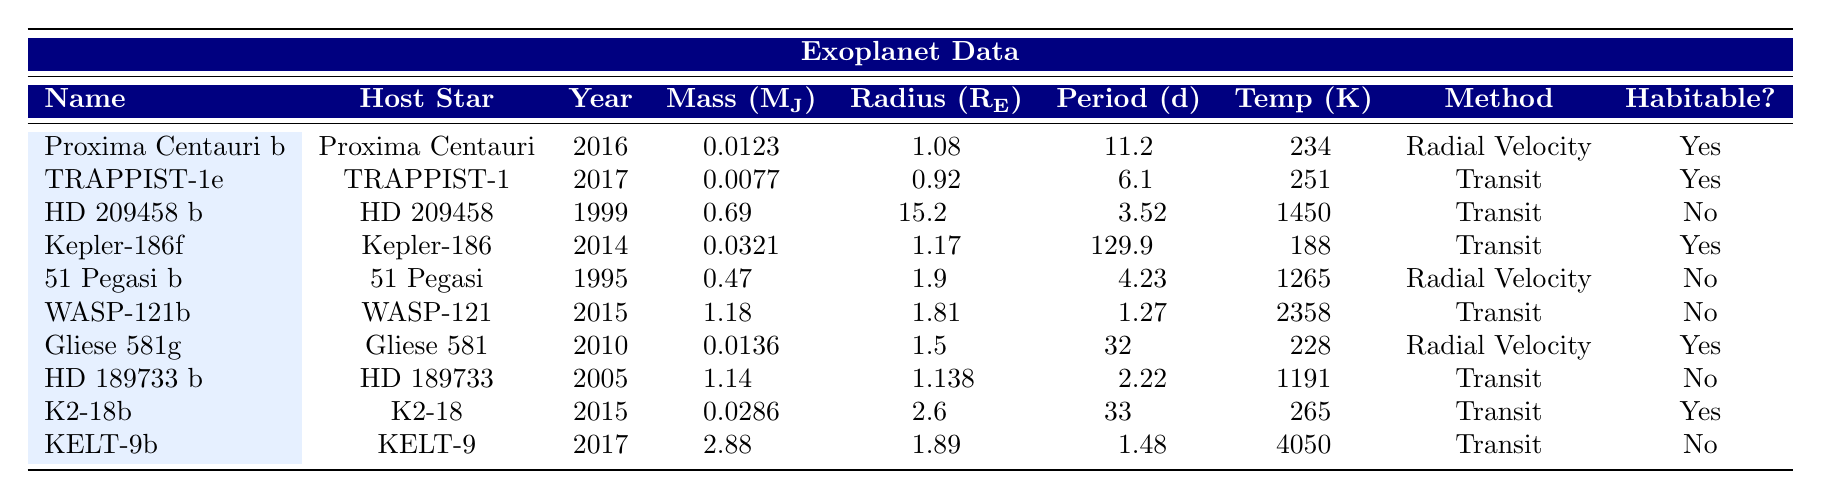What is the host star of Proxima Centauri b? The table lists Proxima Centauri b in the first row, and the associated host star is Proxima Centauri.
Answer: Proxima Centauri What year was K2-18b discovered? The table indicates that K2-18b was discovered in the year listed in its row, which is 2015.
Answer: 2015 Which exoplanet has the highest average temperature? By reviewing the temperature values in the table, KELT-9b has the highest average temperature at 4050 K.
Answer: KELT-9b How many exoplanets in the table are potentially habitable? The table shows three exoplanets with "Yes" in the last column, so there are three potentially habitable exoplanets.
Answer: 3 What is the mass of TRAPPIST-1e in Jupiter masses? The row for TRAPPIST-1e shows a mass of 0.0077 Jupiter masses.
Answer: 0.0077 What is the average mass of the habitable exoplanets listed? The habitable exoplanets and their masses are Proxima Centauri b (0.0123), TRAPPIST-1e (0.0077), Gliese 581g (0.0136), Kepler-186f (0.0321), and K2-18b (0.0286). Adding these gives: 0.0123 + 0.0077 + 0.0136 + 0.0321 + 0.0286 = 0.0943. To find the average, divide by 5 (the number of habitable exoplanets), resulting in an average mass of 0.01886.
Answer: 0.01886 Is there an exoplanet discovered before 2000 that is potentially habitable? According to the table, the only exoplanets discovered before 2000 are 51 Pegasi b and HD 209458 b, both of which are marked as not potentially habitable. Therefore, the answer is no.
Answer: No Which detection method has the most exoplanets listed in the table? By counting the instances of each detection method in their respective rows, "Transit" appears 6 times, while "Radial Velocity" appears 4 times. Thus, "Transit" is the most frequent detection method.
Answer: Transit What is the difference in orbital period between the longest and shortest period exoplanets in the table? The longest orbital period is for Kepler-186f at 129.9 days, and the shortest is for Proxima Centauri b at 11.2 days. The difference is calculated as 129.9 - 11.2 = 118.7 days.
Answer: 118.7 days Which exoplanet has the largest radius in Earth radii? Reviewing the radius values in the table, HD 209458 b has the largest radius at 15.2 Earth radii.
Answer: HD 209458 b What is the average temperature of all non-habitable exoplanets in the table? The non-habitable exoplanets and their temperatures are HD 209458 b (1450), 51 Pegasi b (1265), WASP-121b (2358), HD 189733 b (1191), and KELT-9b (4050). Adding these gives: 1450 + 1265 + 2358 + 1191 + 4050 = 10314. To find the average, divide by 5 (the number of non-habitable exoplanets), resulting in an average temperature of 2062.8 K.
Answer: 2062.8 K 